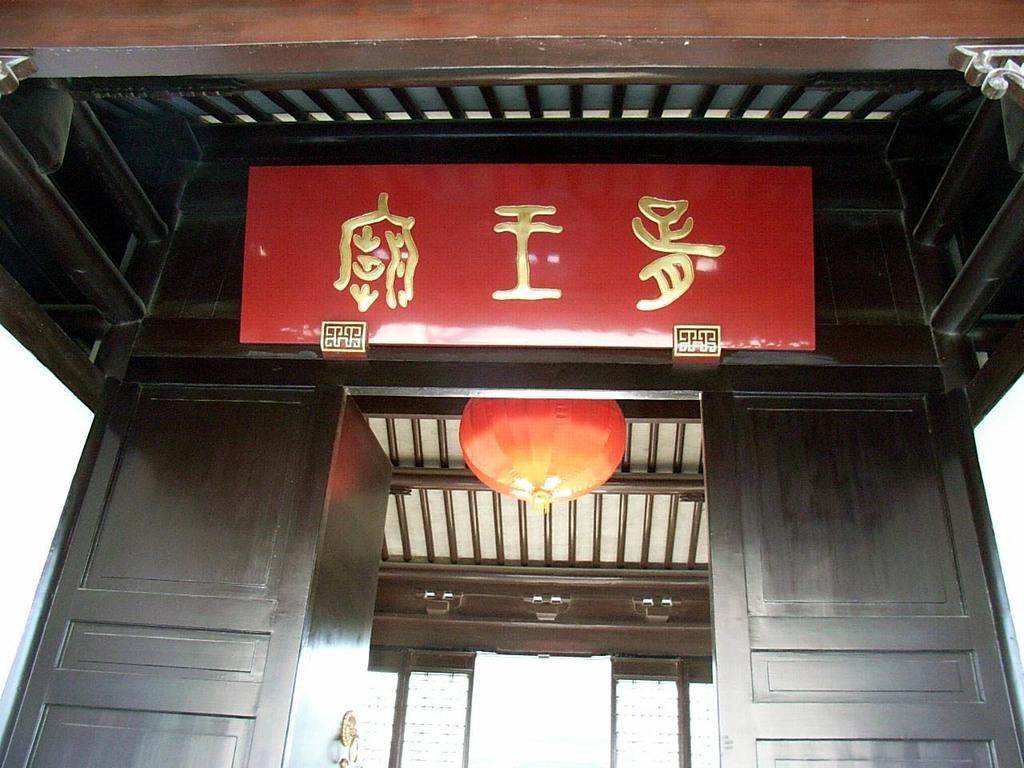How would you summarize this image in a sentence or two? In this image there is a wooden object which is black in colour and there is a board with some text written on it which is in the foreign language and it is in red in colour and there is a light hanging. 